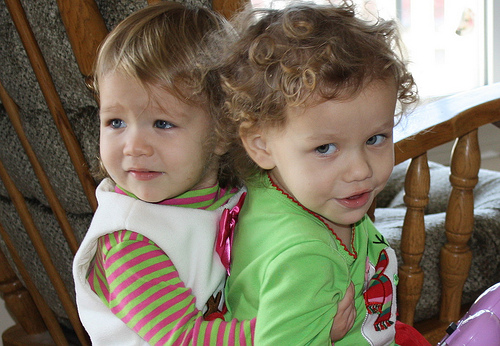<image>
Can you confirm if the girl is on the girl? Yes. Looking at the image, I can see the girl is positioned on top of the girl, with the girl providing support. Is the older sister in front of the younger sister? Yes. The older sister is positioned in front of the younger sister, appearing closer to the camera viewpoint. 